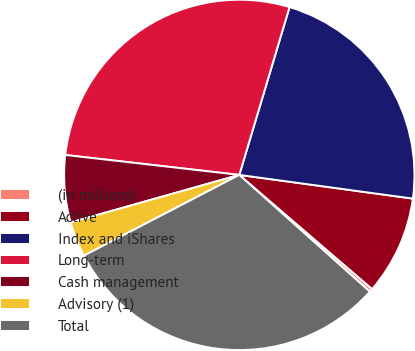Convert chart. <chart><loc_0><loc_0><loc_500><loc_500><pie_chart><fcel>(in millions)<fcel>Active<fcel>Index and iShares<fcel>Long-term<fcel>Cash management<fcel>Advisory (1)<fcel>Total<nl><fcel>0.31%<fcel>9.14%<fcel>22.53%<fcel>27.81%<fcel>6.19%<fcel>3.25%<fcel>30.76%<nl></chart> 